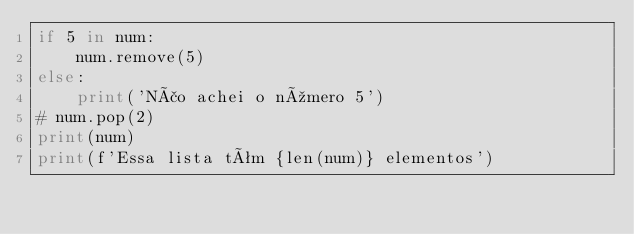<code> <loc_0><loc_0><loc_500><loc_500><_Python_>if 5 in num:
    num.remove(5)
else:
    print('Não achei o número 5')
# num.pop(2)
print(num)
print(f'Essa lista têm {len(num)} elementos')
</code> 